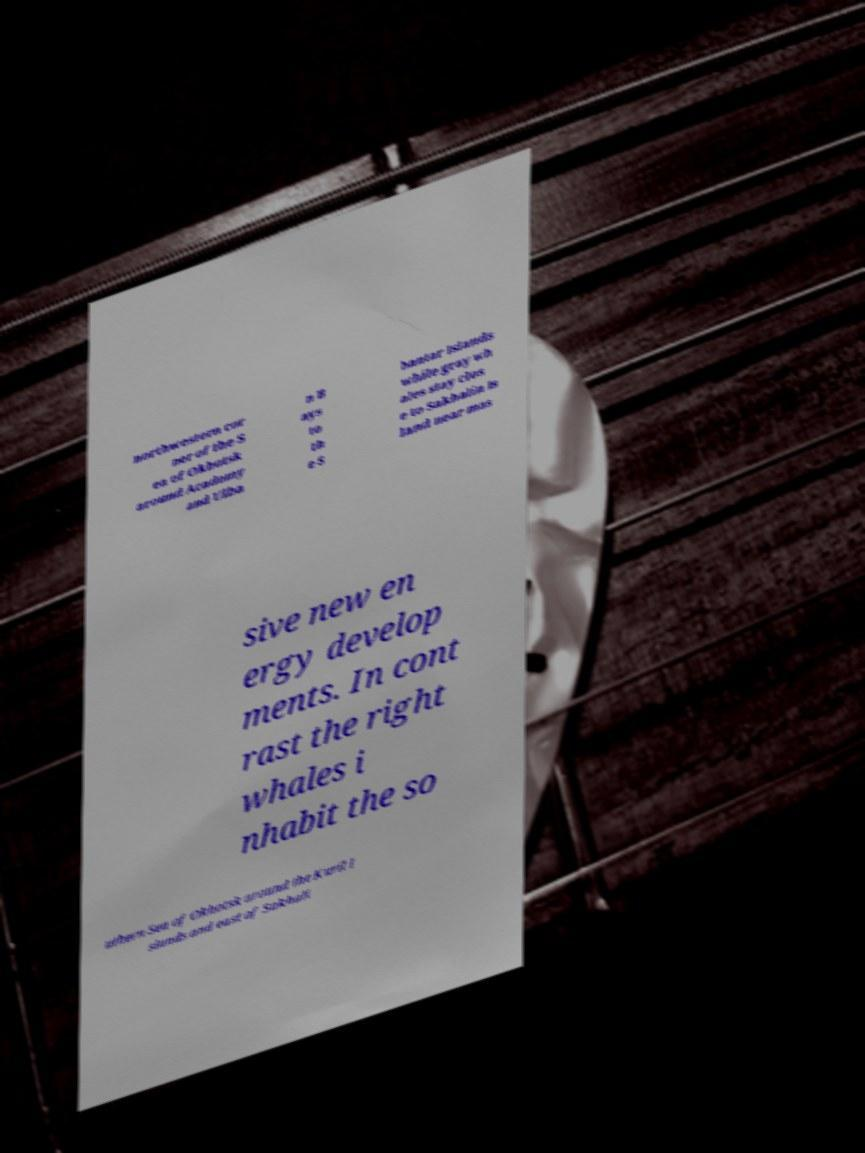Can you accurately transcribe the text from the provided image for me? northwestern cor ner of the S ea of Okhotsk around Academy and Ulba n B ays to th e S hantar Islands while gray wh ales stay clos e to Sakhalin Is land near mas sive new en ergy develop ments. In cont rast the right whales i nhabit the so uthern Sea of Okhotsk around the Kuril I slands and east of Sakhali 